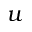Convert formula to latex. <formula><loc_0><loc_0><loc_500><loc_500>u</formula> 